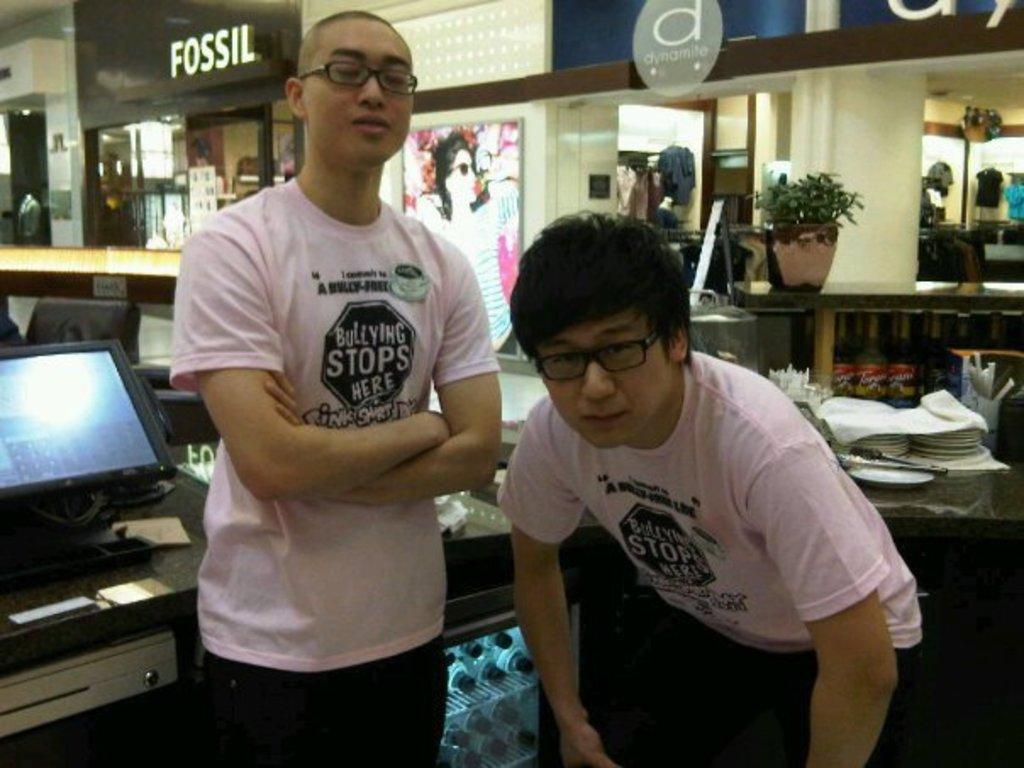Could you give a brief overview of what you see in this image? This picture seems to be clicked inside the hall. In the foreground we can see the two persons wearing t-shirts and we can see the tables on the top of which plates, houseplant, electronic device and some other items are placed. In the background we can see the text and some pictures and we can see many other objects in the background. 